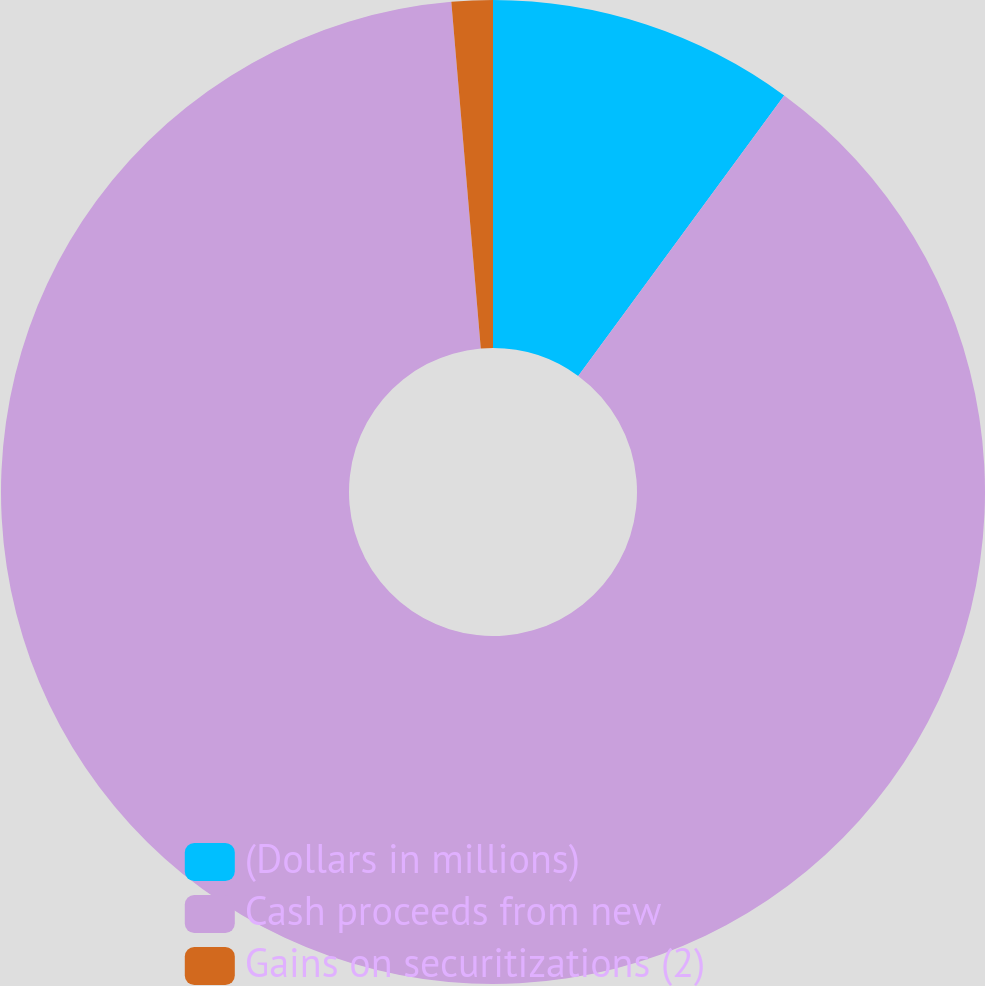<chart> <loc_0><loc_0><loc_500><loc_500><pie_chart><fcel>(Dollars in millions)<fcel>Cash proceeds from new<fcel>Gains on securitizations (2)<nl><fcel>10.08%<fcel>88.57%<fcel>1.35%<nl></chart> 